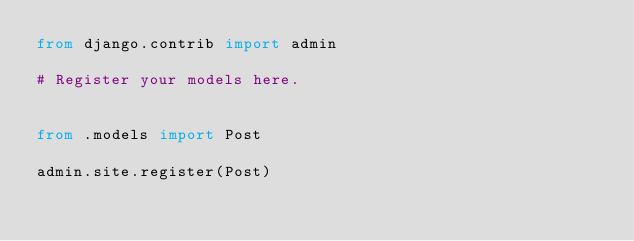Convert code to text. <code><loc_0><loc_0><loc_500><loc_500><_Python_>from django.contrib import admin

# Register your models here.


from .models import Post

admin.site.register(Post)</code> 